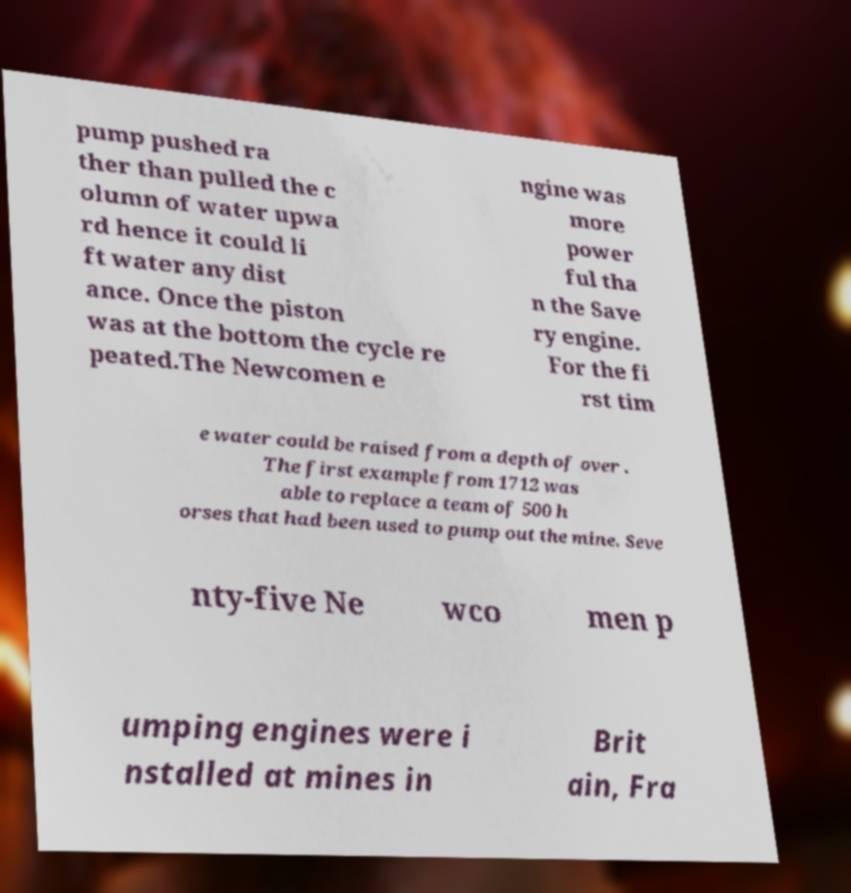Could you extract and type out the text from this image? pump pushed ra ther than pulled the c olumn of water upwa rd hence it could li ft water any dist ance. Once the piston was at the bottom the cycle re peated.The Newcomen e ngine was more power ful tha n the Save ry engine. For the fi rst tim e water could be raised from a depth of over . The first example from 1712 was able to replace a team of 500 h orses that had been used to pump out the mine. Seve nty-five Ne wco men p umping engines were i nstalled at mines in Brit ain, Fra 